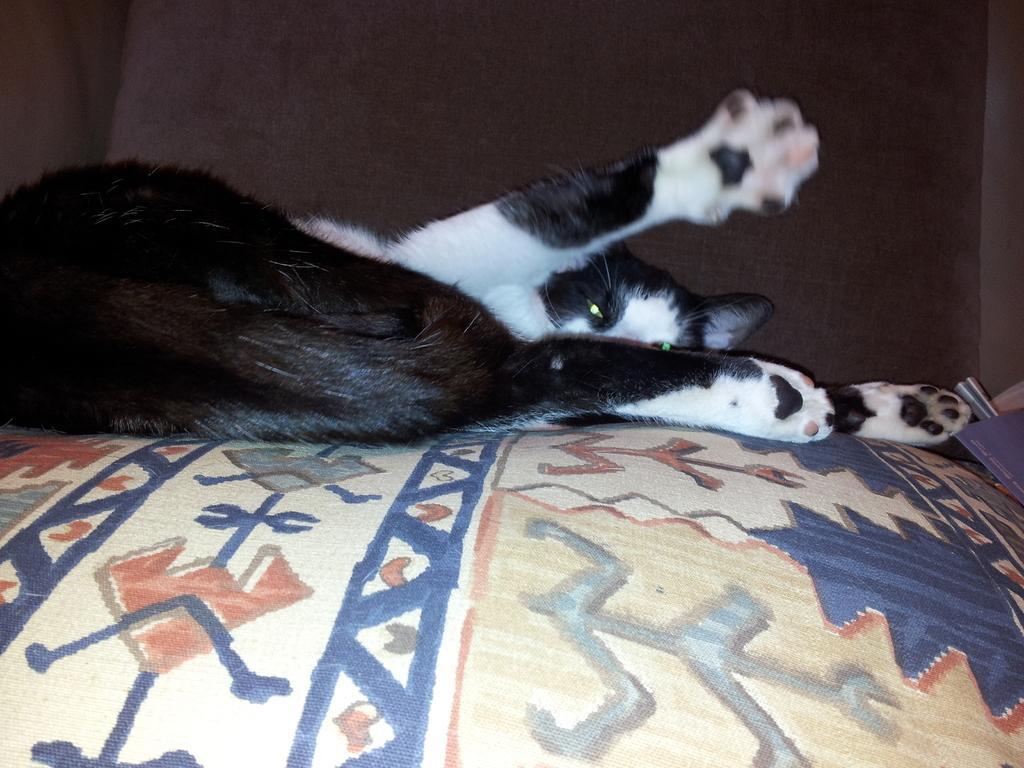Please provide a concise description of this image. There is a black and white color cat sleeping on a pillow, which is on the bed. In the background, there is a wall. 